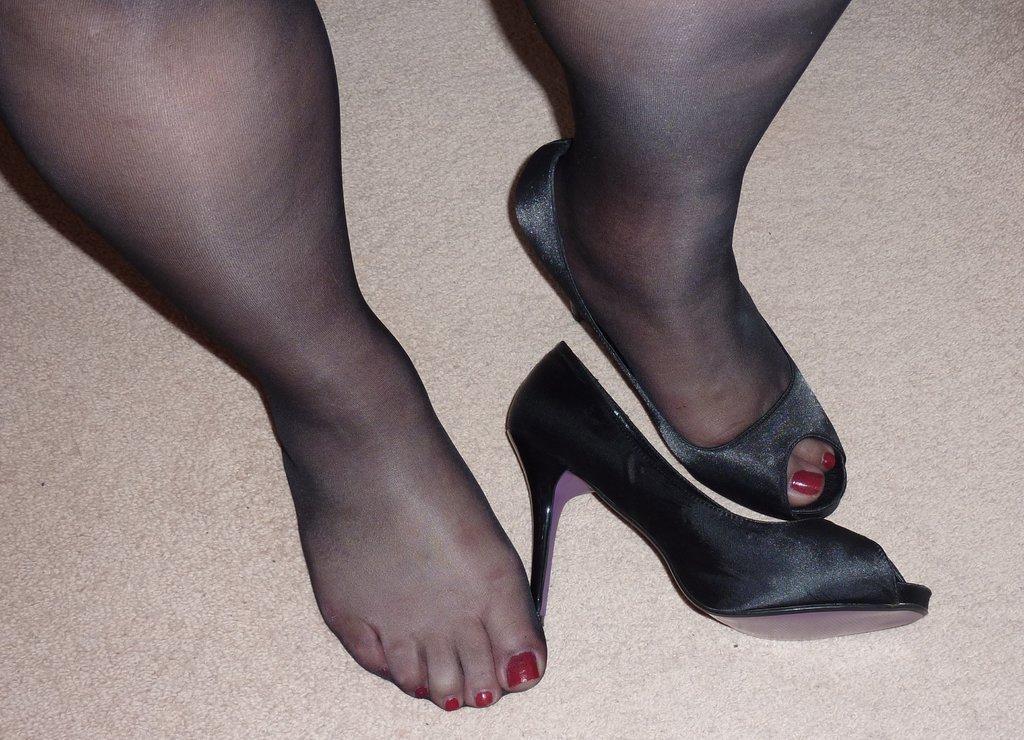In one or two sentences, can you explain what this image depicts? In the center of the image a person legs and sand heels are there. In the background of the image floor is present. 